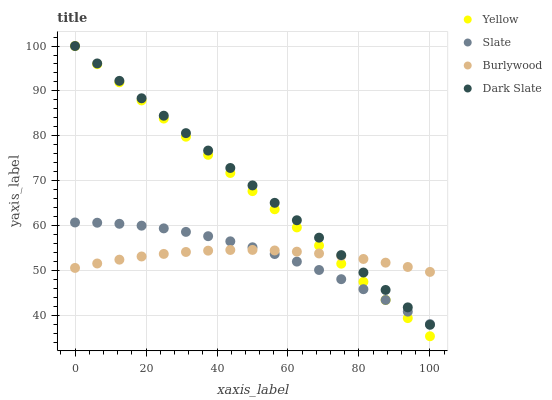Does Burlywood have the minimum area under the curve?
Answer yes or no. Yes. Does Dark Slate have the maximum area under the curve?
Answer yes or no. Yes. Does Slate have the minimum area under the curve?
Answer yes or no. No. Does Slate have the maximum area under the curve?
Answer yes or no. No. Is Yellow the smoothest?
Answer yes or no. Yes. Is Slate the roughest?
Answer yes or no. Yes. Is Dark Slate the smoothest?
Answer yes or no. No. Is Dark Slate the roughest?
Answer yes or no. No. Does Yellow have the lowest value?
Answer yes or no. Yes. Does Dark Slate have the lowest value?
Answer yes or no. No. Does Yellow have the highest value?
Answer yes or no. Yes. Does Slate have the highest value?
Answer yes or no. No. Does Yellow intersect Burlywood?
Answer yes or no. Yes. Is Yellow less than Burlywood?
Answer yes or no. No. Is Yellow greater than Burlywood?
Answer yes or no. No. 